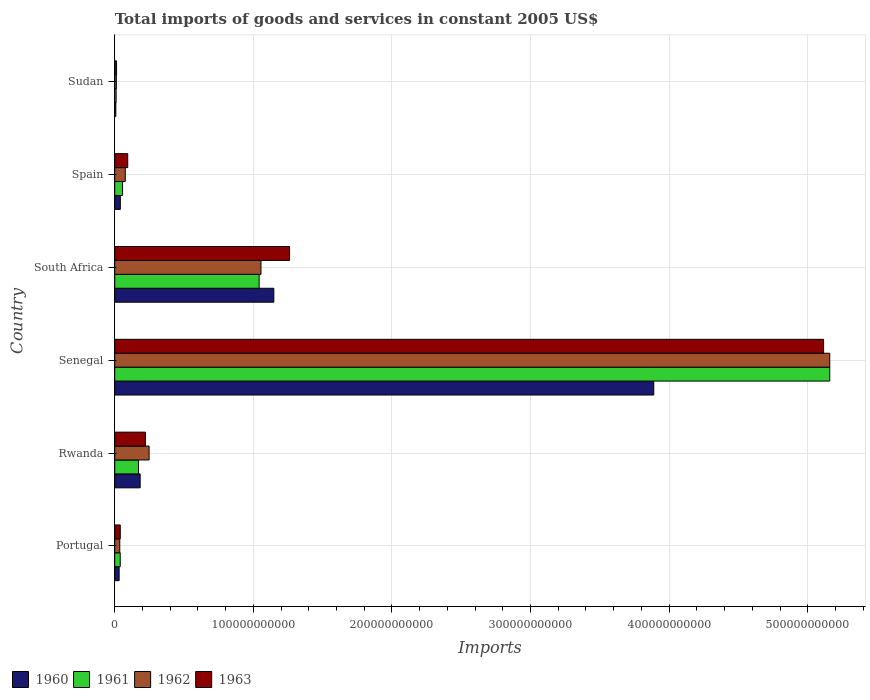How many different coloured bars are there?
Your answer should be very brief. 4. Are the number of bars on each tick of the Y-axis equal?
Make the answer very short. Yes. How many bars are there on the 2nd tick from the top?
Provide a succinct answer. 4. What is the label of the 3rd group of bars from the top?
Offer a terse response. South Africa. What is the total imports of goods and services in 1963 in South Africa?
Your response must be concise. 1.26e+11. Across all countries, what is the maximum total imports of goods and services in 1961?
Your answer should be compact. 5.16e+11. Across all countries, what is the minimum total imports of goods and services in 1961?
Provide a short and direct response. 1.00e+09. In which country was the total imports of goods and services in 1963 maximum?
Your response must be concise. Senegal. In which country was the total imports of goods and services in 1961 minimum?
Offer a terse response. Sudan. What is the total total imports of goods and services in 1963 in the graph?
Offer a terse response. 6.74e+11. What is the difference between the total imports of goods and services in 1960 in Rwanda and that in Spain?
Provide a short and direct response. 1.43e+1. What is the difference between the total imports of goods and services in 1961 in Portugal and the total imports of goods and services in 1960 in Senegal?
Your response must be concise. -3.85e+11. What is the average total imports of goods and services in 1960 per country?
Offer a very short reply. 8.83e+1. What is the difference between the total imports of goods and services in 1962 and total imports of goods and services in 1960 in Sudan?
Your response must be concise. 3.65e+08. In how many countries, is the total imports of goods and services in 1960 greater than 460000000000 US$?
Keep it short and to the point. 0. What is the ratio of the total imports of goods and services in 1962 in Portugal to that in Spain?
Give a very brief answer. 0.48. Is the difference between the total imports of goods and services in 1962 in Rwanda and Senegal greater than the difference between the total imports of goods and services in 1960 in Rwanda and Senegal?
Offer a very short reply. No. What is the difference between the highest and the second highest total imports of goods and services in 1963?
Keep it short and to the point. 3.85e+11. What is the difference between the highest and the lowest total imports of goods and services in 1962?
Provide a short and direct response. 5.15e+11. In how many countries, is the total imports of goods and services in 1962 greater than the average total imports of goods and services in 1962 taken over all countries?
Ensure brevity in your answer.  1. Is it the case that in every country, the sum of the total imports of goods and services in 1962 and total imports of goods and services in 1960 is greater than the sum of total imports of goods and services in 1963 and total imports of goods and services in 1961?
Give a very brief answer. No. Are all the bars in the graph horizontal?
Ensure brevity in your answer.  Yes. What is the difference between two consecutive major ticks on the X-axis?
Ensure brevity in your answer.  1.00e+11. What is the title of the graph?
Provide a succinct answer. Total imports of goods and services in constant 2005 US$. What is the label or title of the X-axis?
Give a very brief answer. Imports. What is the label or title of the Y-axis?
Provide a succinct answer. Country. What is the Imports of 1960 in Portugal?
Ensure brevity in your answer.  3.17e+09. What is the Imports of 1961 in Portugal?
Your response must be concise. 3.96e+09. What is the Imports of 1962 in Portugal?
Keep it short and to the point. 3.62e+09. What is the Imports of 1963 in Portugal?
Ensure brevity in your answer.  3.98e+09. What is the Imports in 1960 in Rwanda?
Provide a succinct answer. 1.83e+1. What is the Imports in 1961 in Rwanda?
Keep it short and to the point. 1.71e+1. What is the Imports in 1962 in Rwanda?
Provide a short and direct response. 2.48e+1. What is the Imports in 1963 in Rwanda?
Keep it short and to the point. 2.21e+1. What is the Imports in 1960 in Senegal?
Offer a terse response. 3.89e+11. What is the Imports in 1961 in Senegal?
Make the answer very short. 5.16e+11. What is the Imports of 1962 in Senegal?
Provide a short and direct response. 5.16e+11. What is the Imports in 1963 in Senegal?
Keep it short and to the point. 5.11e+11. What is the Imports in 1960 in South Africa?
Offer a very short reply. 1.15e+11. What is the Imports of 1961 in South Africa?
Your response must be concise. 1.04e+11. What is the Imports of 1962 in South Africa?
Make the answer very short. 1.05e+11. What is the Imports in 1963 in South Africa?
Your response must be concise. 1.26e+11. What is the Imports of 1960 in Spain?
Your answer should be compact. 4.02e+09. What is the Imports of 1961 in Spain?
Keep it short and to the point. 5.64e+09. What is the Imports of 1962 in Spain?
Your answer should be very brief. 7.58e+09. What is the Imports in 1963 in Spain?
Offer a very short reply. 9.36e+09. What is the Imports in 1960 in Sudan?
Provide a succinct answer. 7.79e+08. What is the Imports of 1961 in Sudan?
Give a very brief answer. 1.00e+09. What is the Imports of 1962 in Sudan?
Your answer should be very brief. 1.14e+09. What is the Imports of 1963 in Sudan?
Give a very brief answer. 1.28e+09. Across all countries, what is the maximum Imports in 1960?
Give a very brief answer. 3.89e+11. Across all countries, what is the maximum Imports in 1961?
Make the answer very short. 5.16e+11. Across all countries, what is the maximum Imports of 1962?
Keep it short and to the point. 5.16e+11. Across all countries, what is the maximum Imports of 1963?
Offer a terse response. 5.11e+11. Across all countries, what is the minimum Imports of 1960?
Offer a very short reply. 7.79e+08. Across all countries, what is the minimum Imports of 1961?
Keep it short and to the point. 1.00e+09. Across all countries, what is the minimum Imports of 1962?
Your response must be concise. 1.14e+09. Across all countries, what is the minimum Imports of 1963?
Offer a very short reply. 1.28e+09. What is the total Imports in 1960 in the graph?
Offer a terse response. 5.30e+11. What is the total Imports in 1961 in the graph?
Give a very brief answer. 6.48e+11. What is the total Imports of 1962 in the graph?
Your response must be concise. 6.59e+11. What is the total Imports in 1963 in the graph?
Your answer should be very brief. 6.74e+11. What is the difference between the Imports of 1960 in Portugal and that in Rwanda?
Your answer should be very brief. -1.52e+1. What is the difference between the Imports of 1961 in Portugal and that in Rwanda?
Your response must be concise. -1.32e+1. What is the difference between the Imports in 1962 in Portugal and that in Rwanda?
Provide a succinct answer. -2.12e+1. What is the difference between the Imports in 1963 in Portugal and that in Rwanda?
Your answer should be very brief. -1.81e+1. What is the difference between the Imports in 1960 in Portugal and that in Senegal?
Your answer should be very brief. -3.86e+11. What is the difference between the Imports of 1961 in Portugal and that in Senegal?
Ensure brevity in your answer.  -5.12e+11. What is the difference between the Imports in 1962 in Portugal and that in Senegal?
Your answer should be very brief. -5.12e+11. What is the difference between the Imports in 1963 in Portugal and that in Senegal?
Offer a terse response. -5.07e+11. What is the difference between the Imports in 1960 in Portugal and that in South Africa?
Keep it short and to the point. -1.12e+11. What is the difference between the Imports of 1961 in Portugal and that in South Africa?
Provide a short and direct response. -1.00e+11. What is the difference between the Imports in 1962 in Portugal and that in South Africa?
Offer a very short reply. -1.02e+11. What is the difference between the Imports of 1963 in Portugal and that in South Africa?
Keep it short and to the point. -1.22e+11. What is the difference between the Imports of 1960 in Portugal and that in Spain?
Your answer should be very brief. -8.56e+08. What is the difference between the Imports in 1961 in Portugal and that in Spain?
Provide a short and direct response. -1.68e+09. What is the difference between the Imports in 1962 in Portugal and that in Spain?
Ensure brevity in your answer.  -3.96e+09. What is the difference between the Imports of 1963 in Portugal and that in Spain?
Provide a succinct answer. -5.39e+09. What is the difference between the Imports of 1960 in Portugal and that in Sudan?
Your response must be concise. 2.39e+09. What is the difference between the Imports of 1961 in Portugal and that in Sudan?
Your answer should be very brief. 2.95e+09. What is the difference between the Imports in 1962 in Portugal and that in Sudan?
Your answer should be very brief. 2.48e+09. What is the difference between the Imports of 1963 in Portugal and that in Sudan?
Your answer should be compact. 2.69e+09. What is the difference between the Imports of 1960 in Rwanda and that in Senegal?
Make the answer very short. -3.71e+11. What is the difference between the Imports in 1961 in Rwanda and that in Senegal?
Offer a very short reply. -4.99e+11. What is the difference between the Imports in 1962 in Rwanda and that in Senegal?
Give a very brief answer. -4.91e+11. What is the difference between the Imports of 1963 in Rwanda and that in Senegal?
Offer a very short reply. -4.89e+11. What is the difference between the Imports of 1960 in Rwanda and that in South Africa?
Your answer should be very brief. -9.65e+1. What is the difference between the Imports of 1961 in Rwanda and that in South Africa?
Give a very brief answer. -8.71e+1. What is the difference between the Imports in 1962 in Rwanda and that in South Africa?
Make the answer very short. -8.07e+1. What is the difference between the Imports of 1963 in Rwanda and that in South Africa?
Ensure brevity in your answer.  -1.04e+11. What is the difference between the Imports in 1960 in Rwanda and that in Spain?
Your answer should be compact. 1.43e+1. What is the difference between the Imports of 1961 in Rwanda and that in Spain?
Your answer should be compact. 1.15e+1. What is the difference between the Imports of 1962 in Rwanda and that in Spain?
Keep it short and to the point. 1.72e+1. What is the difference between the Imports in 1963 in Rwanda and that in Spain?
Give a very brief answer. 1.27e+1. What is the difference between the Imports in 1960 in Rwanda and that in Sudan?
Ensure brevity in your answer.  1.75e+1. What is the difference between the Imports of 1961 in Rwanda and that in Sudan?
Provide a succinct answer. 1.61e+1. What is the difference between the Imports of 1962 in Rwanda and that in Sudan?
Keep it short and to the point. 2.36e+1. What is the difference between the Imports of 1963 in Rwanda and that in Sudan?
Make the answer very short. 2.08e+1. What is the difference between the Imports in 1960 in Senegal and that in South Africa?
Your answer should be very brief. 2.74e+11. What is the difference between the Imports in 1961 in Senegal and that in South Africa?
Offer a very short reply. 4.12e+11. What is the difference between the Imports in 1962 in Senegal and that in South Africa?
Keep it short and to the point. 4.10e+11. What is the difference between the Imports in 1963 in Senegal and that in South Africa?
Keep it short and to the point. 3.85e+11. What is the difference between the Imports in 1960 in Senegal and that in Spain?
Offer a terse response. 3.85e+11. What is the difference between the Imports in 1961 in Senegal and that in Spain?
Keep it short and to the point. 5.10e+11. What is the difference between the Imports in 1962 in Senegal and that in Spain?
Offer a terse response. 5.08e+11. What is the difference between the Imports in 1963 in Senegal and that in Spain?
Give a very brief answer. 5.02e+11. What is the difference between the Imports in 1960 in Senegal and that in Sudan?
Keep it short and to the point. 3.88e+11. What is the difference between the Imports in 1961 in Senegal and that in Sudan?
Provide a succinct answer. 5.15e+11. What is the difference between the Imports in 1962 in Senegal and that in Sudan?
Give a very brief answer. 5.15e+11. What is the difference between the Imports in 1963 in Senegal and that in Sudan?
Your response must be concise. 5.10e+11. What is the difference between the Imports in 1960 in South Africa and that in Spain?
Provide a short and direct response. 1.11e+11. What is the difference between the Imports of 1961 in South Africa and that in Spain?
Ensure brevity in your answer.  9.85e+1. What is the difference between the Imports of 1962 in South Africa and that in Spain?
Your response must be concise. 9.79e+1. What is the difference between the Imports of 1963 in South Africa and that in Spain?
Ensure brevity in your answer.  1.17e+11. What is the difference between the Imports in 1960 in South Africa and that in Sudan?
Offer a very short reply. 1.14e+11. What is the difference between the Imports of 1961 in South Africa and that in Sudan?
Provide a succinct answer. 1.03e+11. What is the difference between the Imports in 1962 in South Africa and that in Sudan?
Offer a very short reply. 1.04e+11. What is the difference between the Imports of 1963 in South Africa and that in Sudan?
Provide a short and direct response. 1.25e+11. What is the difference between the Imports in 1960 in Spain and that in Sudan?
Keep it short and to the point. 3.24e+09. What is the difference between the Imports of 1961 in Spain and that in Sudan?
Provide a succinct answer. 4.63e+09. What is the difference between the Imports of 1962 in Spain and that in Sudan?
Ensure brevity in your answer.  6.44e+09. What is the difference between the Imports of 1963 in Spain and that in Sudan?
Offer a terse response. 8.08e+09. What is the difference between the Imports of 1960 in Portugal and the Imports of 1961 in Rwanda?
Provide a short and direct response. -1.39e+1. What is the difference between the Imports of 1960 in Portugal and the Imports of 1962 in Rwanda?
Your answer should be compact. -2.16e+1. What is the difference between the Imports of 1960 in Portugal and the Imports of 1963 in Rwanda?
Your answer should be very brief. -1.89e+1. What is the difference between the Imports in 1961 in Portugal and the Imports in 1962 in Rwanda?
Offer a very short reply. -2.08e+1. What is the difference between the Imports in 1961 in Portugal and the Imports in 1963 in Rwanda?
Ensure brevity in your answer.  -1.81e+1. What is the difference between the Imports in 1962 in Portugal and the Imports in 1963 in Rwanda?
Your answer should be compact. -1.85e+1. What is the difference between the Imports in 1960 in Portugal and the Imports in 1961 in Senegal?
Provide a succinct answer. -5.13e+11. What is the difference between the Imports in 1960 in Portugal and the Imports in 1962 in Senegal?
Your answer should be compact. -5.13e+11. What is the difference between the Imports in 1960 in Portugal and the Imports in 1963 in Senegal?
Your answer should be compact. -5.08e+11. What is the difference between the Imports in 1961 in Portugal and the Imports in 1962 in Senegal?
Provide a short and direct response. -5.12e+11. What is the difference between the Imports in 1961 in Portugal and the Imports in 1963 in Senegal?
Offer a very short reply. -5.07e+11. What is the difference between the Imports in 1962 in Portugal and the Imports in 1963 in Senegal?
Provide a succinct answer. -5.08e+11. What is the difference between the Imports of 1960 in Portugal and the Imports of 1961 in South Africa?
Offer a very short reply. -1.01e+11. What is the difference between the Imports of 1960 in Portugal and the Imports of 1962 in South Africa?
Offer a very short reply. -1.02e+11. What is the difference between the Imports of 1960 in Portugal and the Imports of 1963 in South Africa?
Ensure brevity in your answer.  -1.23e+11. What is the difference between the Imports of 1961 in Portugal and the Imports of 1962 in South Africa?
Your response must be concise. -1.02e+11. What is the difference between the Imports in 1961 in Portugal and the Imports in 1963 in South Africa?
Keep it short and to the point. -1.22e+11. What is the difference between the Imports of 1962 in Portugal and the Imports of 1963 in South Africa?
Offer a terse response. -1.23e+11. What is the difference between the Imports in 1960 in Portugal and the Imports in 1961 in Spain?
Ensure brevity in your answer.  -2.47e+09. What is the difference between the Imports in 1960 in Portugal and the Imports in 1962 in Spain?
Your answer should be very brief. -4.41e+09. What is the difference between the Imports in 1960 in Portugal and the Imports in 1963 in Spain?
Make the answer very short. -6.19e+09. What is the difference between the Imports of 1961 in Portugal and the Imports of 1962 in Spain?
Provide a short and direct response. -3.62e+09. What is the difference between the Imports in 1961 in Portugal and the Imports in 1963 in Spain?
Offer a very short reply. -5.41e+09. What is the difference between the Imports of 1962 in Portugal and the Imports of 1963 in Spain?
Your response must be concise. -5.74e+09. What is the difference between the Imports in 1960 in Portugal and the Imports in 1961 in Sudan?
Your answer should be compact. 2.16e+09. What is the difference between the Imports of 1960 in Portugal and the Imports of 1962 in Sudan?
Provide a short and direct response. 2.02e+09. What is the difference between the Imports in 1960 in Portugal and the Imports in 1963 in Sudan?
Your response must be concise. 1.88e+09. What is the difference between the Imports in 1961 in Portugal and the Imports in 1962 in Sudan?
Ensure brevity in your answer.  2.81e+09. What is the difference between the Imports in 1961 in Portugal and the Imports in 1963 in Sudan?
Keep it short and to the point. 2.67e+09. What is the difference between the Imports in 1962 in Portugal and the Imports in 1963 in Sudan?
Give a very brief answer. 2.34e+09. What is the difference between the Imports in 1960 in Rwanda and the Imports in 1961 in Senegal?
Your response must be concise. -4.98e+11. What is the difference between the Imports in 1960 in Rwanda and the Imports in 1962 in Senegal?
Provide a succinct answer. -4.98e+11. What is the difference between the Imports in 1960 in Rwanda and the Imports in 1963 in Senegal?
Provide a short and direct response. -4.93e+11. What is the difference between the Imports in 1961 in Rwanda and the Imports in 1962 in Senegal?
Offer a very short reply. -4.99e+11. What is the difference between the Imports of 1961 in Rwanda and the Imports of 1963 in Senegal?
Make the answer very short. -4.94e+11. What is the difference between the Imports in 1962 in Rwanda and the Imports in 1963 in Senegal?
Give a very brief answer. -4.87e+11. What is the difference between the Imports in 1960 in Rwanda and the Imports in 1961 in South Africa?
Your response must be concise. -8.59e+1. What is the difference between the Imports in 1960 in Rwanda and the Imports in 1962 in South Africa?
Your response must be concise. -8.72e+1. What is the difference between the Imports in 1960 in Rwanda and the Imports in 1963 in South Africa?
Ensure brevity in your answer.  -1.08e+11. What is the difference between the Imports of 1961 in Rwanda and the Imports of 1962 in South Africa?
Provide a succinct answer. -8.84e+1. What is the difference between the Imports in 1961 in Rwanda and the Imports in 1963 in South Africa?
Keep it short and to the point. -1.09e+11. What is the difference between the Imports in 1962 in Rwanda and the Imports in 1963 in South Africa?
Your answer should be very brief. -1.01e+11. What is the difference between the Imports in 1960 in Rwanda and the Imports in 1961 in Spain?
Your response must be concise. 1.27e+1. What is the difference between the Imports in 1960 in Rwanda and the Imports in 1962 in Spain?
Offer a terse response. 1.07e+1. What is the difference between the Imports in 1960 in Rwanda and the Imports in 1963 in Spain?
Ensure brevity in your answer.  8.96e+09. What is the difference between the Imports of 1961 in Rwanda and the Imports of 1962 in Spain?
Provide a succinct answer. 9.53e+09. What is the difference between the Imports of 1961 in Rwanda and the Imports of 1963 in Spain?
Give a very brief answer. 7.74e+09. What is the difference between the Imports in 1962 in Rwanda and the Imports in 1963 in Spain?
Provide a short and direct response. 1.54e+1. What is the difference between the Imports of 1960 in Rwanda and the Imports of 1961 in Sudan?
Offer a terse response. 1.73e+1. What is the difference between the Imports in 1960 in Rwanda and the Imports in 1962 in Sudan?
Give a very brief answer. 1.72e+1. What is the difference between the Imports in 1960 in Rwanda and the Imports in 1963 in Sudan?
Make the answer very short. 1.70e+1. What is the difference between the Imports of 1961 in Rwanda and the Imports of 1962 in Sudan?
Ensure brevity in your answer.  1.60e+1. What is the difference between the Imports in 1961 in Rwanda and the Imports in 1963 in Sudan?
Offer a very short reply. 1.58e+1. What is the difference between the Imports in 1962 in Rwanda and the Imports in 1963 in Sudan?
Provide a short and direct response. 2.35e+1. What is the difference between the Imports in 1960 in Senegal and the Imports in 1961 in South Africa?
Your answer should be compact. 2.85e+11. What is the difference between the Imports in 1960 in Senegal and the Imports in 1962 in South Africa?
Provide a succinct answer. 2.83e+11. What is the difference between the Imports of 1960 in Senegal and the Imports of 1963 in South Africa?
Make the answer very short. 2.63e+11. What is the difference between the Imports of 1961 in Senegal and the Imports of 1962 in South Africa?
Ensure brevity in your answer.  4.10e+11. What is the difference between the Imports of 1961 in Senegal and the Imports of 1963 in South Africa?
Your response must be concise. 3.90e+11. What is the difference between the Imports in 1962 in Senegal and the Imports in 1963 in South Africa?
Provide a succinct answer. 3.90e+11. What is the difference between the Imports of 1960 in Senegal and the Imports of 1961 in Spain?
Provide a succinct answer. 3.83e+11. What is the difference between the Imports of 1960 in Senegal and the Imports of 1962 in Spain?
Offer a terse response. 3.81e+11. What is the difference between the Imports in 1960 in Senegal and the Imports in 1963 in Spain?
Provide a short and direct response. 3.80e+11. What is the difference between the Imports in 1961 in Senegal and the Imports in 1962 in Spain?
Give a very brief answer. 5.08e+11. What is the difference between the Imports of 1961 in Senegal and the Imports of 1963 in Spain?
Keep it short and to the point. 5.07e+11. What is the difference between the Imports of 1962 in Senegal and the Imports of 1963 in Spain?
Make the answer very short. 5.07e+11. What is the difference between the Imports of 1960 in Senegal and the Imports of 1961 in Sudan?
Provide a succinct answer. 3.88e+11. What is the difference between the Imports of 1960 in Senegal and the Imports of 1962 in Sudan?
Provide a succinct answer. 3.88e+11. What is the difference between the Imports of 1960 in Senegal and the Imports of 1963 in Sudan?
Offer a terse response. 3.88e+11. What is the difference between the Imports in 1961 in Senegal and the Imports in 1962 in Sudan?
Keep it short and to the point. 5.15e+11. What is the difference between the Imports of 1961 in Senegal and the Imports of 1963 in Sudan?
Give a very brief answer. 5.15e+11. What is the difference between the Imports in 1962 in Senegal and the Imports in 1963 in Sudan?
Make the answer very short. 5.15e+11. What is the difference between the Imports of 1960 in South Africa and the Imports of 1961 in Spain?
Your answer should be very brief. 1.09e+11. What is the difference between the Imports in 1960 in South Africa and the Imports in 1962 in Spain?
Ensure brevity in your answer.  1.07e+11. What is the difference between the Imports in 1960 in South Africa and the Imports in 1963 in Spain?
Your response must be concise. 1.05e+11. What is the difference between the Imports of 1961 in South Africa and the Imports of 1962 in Spain?
Give a very brief answer. 9.66e+1. What is the difference between the Imports of 1961 in South Africa and the Imports of 1963 in Spain?
Your answer should be very brief. 9.48e+1. What is the difference between the Imports in 1962 in South Africa and the Imports in 1963 in Spain?
Provide a short and direct response. 9.61e+1. What is the difference between the Imports of 1960 in South Africa and the Imports of 1961 in Sudan?
Offer a terse response. 1.14e+11. What is the difference between the Imports in 1960 in South Africa and the Imports in 1962 in Sudan?
Offer a very short reply. 1.14e+11. What is the difference between the Imports in 1960 in South Africa and the Imports in 1963 in Sudan?
Your response must be concise. 1.13e+11. What is the difference between the Imports in 1961 in South Africa and the Imports in 1962 in Sudan?
Offer a terse response. 1.03e+11. What is the difference between the Imports of 1961 in South Africa and the Imports of 1963 in Sudan?
Offer a very short reply. 1.03e+11. What is the difference between the Imports in 1962 in South Africa and the Imports in 1963 in Sudan?
Your response must be concise. 1.04e+11. What is the difference between the Imports in 1960 in Spain and the Imports in 1961 in Sudan?
Provide a succinct answer. 3.02e+09. What is the difference between the Imports in 1960 in Spain and the Imports in 1962 in Sudan?
Keep it short and to the point. 2.88e+09. What is the difference between the Imports in 1960 in Spain and the Imports in 1963 in Sudan?
Provide a succinct answer. 2.74e+09. What is the difference between the Imports of 1961 in Spain and the Imports of 1962 in Sudan?
Your answer should be compact. 4.49e+09. What is the difference between the Imports in 1961 in Spain and the Imports in 1963 in Sudan?
Give a very brief answer. 4.35e+09. What is the difference between the Imports of 1962 in Spain and the Imports of 1963 in Sudan?
Make the answer very short. 6.30e+09. What is the average Imports in 1960 per country?
Offer a terse response. 8.83e+1. What is the average Imports in 1961 per country?
Your answer should be very brief. 1.08e+11. What is the average Imports in 1962 per country?
Make the answer very short. 1.10e+11. What is the average Imports of 1963 per country?
Provide a short and direct response. 1.12e+11. What is the difference between the Imports of 1960 and Imports of 1961 in Portugal?
Your response must be concise. -7.89e+08. What is the difference between the Imports of 1960 and Imports of 1962 in Portugal?
Your answer should be very brief. -4.52e+08. What is the difference between the Imports of 1960 and Imports of 1963 in Portugal?
Offer a very short reply. -8.09e+08. What is the difference between the Imports of 1961 and Imports of 1962 in Portugal?
Make the answer very short. 3.37e+08. What is the difference between the Imports in 1961 and Imports in 1963 in Portugal?
Offer a terse response. -2.01e+07. What is the difference between the Imports of 1962 and Imports of 1963 in Portugal?
Your response must be concise. -3.57e+08. What is the difference between the Imports in 1960 and Imports in 1961 in Rwanda?
Offer a terse response. 1.22e+09. What is the difference between the Imports in 1960 and Imports in 1962 in Rwanda?
Give a very brief answer. -6.46e+09. What is the difference between the Imports in 1960 and Imports in 1963 in Rwanda?
Your answer should be very brief. -3.77e+09. What is the difference between the Imports in 1961 and Imports in 1962 in Rwanda?
Give a very brief answer. -7.68e+09. What is the difference between the Imports in 1961 and Imports in 1963 in Rwanda?
Provide a short and direct response. -4.99e+09. What is the difference between the Imports of 1962 and Imports of 1963 in Rwanda?
Offer a terse response. 2.68e+09. What is the difference between the Imports of 1960 and Imports of 1961 in Senegal?
Your answer should be very brief. -1.27e+11. What is the difference between the Imports of 1960 and Imports of 1962 in Senegal?
Ensure brevity in your answer.  -1.27e+11. What is the difference between the Imports of 1960 and Imports of 1963 in Senegal?
Offer a terse response. -1.23e+11. What is the difference between the Imports of 1961 and Imports of 1963 in Senegal?
Provide a succinct answer. 4.44e+09. What is the difference between the Imports in 1962 and Imports in 1963 in Senegal?
Your answer should be compact. 4.44e+09. What is the difference between the Imports in 1960 and Imports in 1961 in South Africa?
Offer a very short reply. 1.06e+1. What is the difference between the Imports of 1960 and Imports of 1962 in South Africa?
Your answer should be compact. 9.28e+09. What is the difference between the Imports of 1960 and Imports of 1963 in South Africa?
Provide a succinct answer. -1.13e+1. What is the difference between the Imports of 1961 and Imports of 1962 in South Africa?
Offer a terse response. -1.32e+09. What is the difference between the Imports of 1961 and Imports of 1963 in South Africa?
Offer a terse response. -2.19e+1. What is the difference between the Imports in 1962 and Imports in 1963 in South Africa?
Offer a very short reply. -2.06e+1. What is the difference between the Imports in 1960 and Imports in 1961 in Spain?
Provide a succinct answer. -1.61e+09. What is the difference between the Imports in 1960 and Imports in 1962 in Spain?
Provide a succinct answer. -3.56e+09. What is the difference between the Imports in 1960 and Imports in 1963 in Spain?
Offer a terse response. -5.34e+09. What is the difference between the Imports of 1961 and Imports of 1962 in Spain?
Offer a very short reply. -1.94e+09. What is the difference between the Imports of 1961 and Imports of 1963 in Spain?
Offer a very short reply. -3.72e+09. What is the difference between the Imports of 1962 and Imports of 1963 in Spain?
Your response must be concise. -1.78e+09. What is the difference between the Imports in 1960 and Imports in 1961 in Sudan?
Offer a terse response. -2.25e+08. What is the difference between the Imports in 1960 and Imports in 1962 in Sudan?
Offer a very short reply. -3.65e+08. What is the difference between the Imports of 1960 and Imports of 1963 in Sudan?
Provide a short and direct response. -5.04e+08. What is the difference between the Imports in 1961 and Imports in 1962 in Sudan?
Provide a short and direct response. -1.39e+08. What is the difference between the Imports of 1961 and Imports of 1963 in Sudan?
Keep it short and to the point. -2.79e+08. What is the difference between the Imports of 1962 and Imports of 1963 in Sudan?
Your answer should be compact. -1.39e+08. What is the ratio of the Imports of 1960 in Portugal to that in Rwanda?
Make the answer very short. 0.17. What is the ratio of the Imports of 1961 in Portugal to that in Rwanda?
Give a very brief answer. 0.23. What is the ratio of the Imports in 1962 in Portugal to that in Rwanda?
Ensure brevity in your answer.  0.15. What is the ratio of the Imports of 1963 in Portugal to that in Rwanda?
Provide a succinct answer. 0.18. What is the ratio of the Imports of 1960 in Portugal to that in Senegal?
Ensure brevity in your answer.  0.01. What is the ratio of the Imports of 1961 in Portugal to that in Senegal?
Your response must be concise. 0.01. What is the ratio of the Imports of 1962 in Portugal to that in Senegal?
Ensure brevity in your answer.  0.01. What is the ratio of the Imports of 1963 in Portugal to that in Senegal?
Make the answer very short. 0.01. What is the ratio of the Imports of 1960 in Portugal to that in South Africa?
Your response must be concise. 0.03. What is the ratio of the Imports in 1961 in Portugal to that in South Africa?
Your response must be concise. 0.04. What is the ratio of the Imports of 1962 in Portugal to that in South Africa?
Provide a succinct answer. 0.03. What is the ratio of the Imports in 1963 in Portugal to that in South Africa?
Your answer should be compact. 0.03. What is the ratio of the Imports in 1960 in Portugal to that in Spain?
Keep it short and to the point. 0.79. What is the ratio of the Imports in 1961 in Portugal to that in Spain?
Offer a very short reply. 0.7. What is the ratio of the Imports in 1962 in Portugal to that in Spain?
Keep it short and to the point. 0.48. What is the ratio of the Imports of 1963 in Portugal to that in Spain?
Your answer should be compact. 0.42. What is the ratio of the Imports in 1960 in Portugal to that in Sudan?
Give a very brief answer. 4.06. What is the ratio of the Imports of 1961 in Portugal to that in Sudan?
Offer a very short reply. 3.94. What is the ratio of the Imports of 1962 in Portugal to that in Sudan?
Keep it short and to the point. 3.16. What is the ratio of the Imports in 1963 in Portugal to that in Sudan?
Your answer should be very brief. 3.1. What is the ratio of the Imports of 1960 in Rwanda to that in Senegal?
Your answer should be compact. 0.05. What is the ratio of the Imports of 1961 in Rwanda to that in Senegal?
Provide a short and direct response. 0.03. What is the ratio of the Imports in 1962 in Rwanda to that in Senegal?
Make the answer very short. 0.05. What is the ratio of the Imports in 1963 in Rwanda to that in Senegal?
Give a very brief answer. 0.04. What is the ratio of the Imports in 1960 in Rwanda to that in South Africa?
Your answer should be compact. 0.16. What is the ratio of the Imports in 1961 in Rwanda to that in South Africa?
Your answer should be compact. 0.16. What is the ratio of the Imports in 1962 in Rwanda to that in South Africa?
Offer a terse response. 0.23. What is the ratio of the Imports in 1963 in Rwanda to that in South Africa?
Offer a terse response. 0.18. What is the ratio of the Imports of 1960 in Rwanda to that in Spain?
Offer a terse response. 4.55. What is the ratio of the Imports in 1961 in Rwanda to that in Spain?
Ensure brevity in your answer.  3.03. What is the ratio of the Imports in 1962 in Rwanda to that in Spain?
Offer a terse response. 3.27. What is the ratio of the Imports of 1963 in Rwanda to that in Spain?
Keep it short and to the point. 2.36. What is the ratio of the Imports of 1960 in Rwanda to that in Sudan?
Make the answer very short. 23.52. What is the ratio of the Imports of 1961 in Rwanda to that in Sudan?
Ensure brevity in your answer.  17.03. What is the ratio of the Imports of 1962 in Rwanda to that in Sudan?
Provide a short and direct response. 21.67. What is the ratio of the Imports in 1963 in Rwanda to that in Sudan?
Your answer should be compact. 17.22. What is the ratio of the Imports of 1960 in Senegal to that in South Africa?
Your answer should be compact. 3.39. What is the ratio of the Imports in 1961 in Senegal to that in South Africa?
Keep it short and to the point. 4.95. What is the ratio of the Imports of 1962 in Senegal to that in South Africa?
Your answer should be compact. 4.89. What is the ratio of the Imports of 1963 in Senegal to that in South Africa?
Your answer should be compact. 4.06. What is the ratio of the Imports in 1960 in Senegal to that in Spain?
Make the answer very short. 96.67. What is the ratio of the Imports of 1961 in Senegal to that in Spain?
Offer a terse response. 91.51. What is the ratio of the Imports of 1962 in Senegal to that in Spain?
Provide a succinct answer. 68.06. What is the ratio of the Imports of 1963 in Senegal to that in Spain?
Provide a succinct answer. 54.63. What is the ratio of the Imports in 1960 in Senegal to that in Sudan?
Keep it short and to the point. 499.07. What is the ratio of the Imports in 1961 in Senegal to that in Sudan?
Ensure brevity in your answer.  513.64. What is the ratio of the Imports in 1962 in Senegal to that in Sudan?
Your response must be concise. 451.01. What is the ratio of the Imports in 1963 in Senegal to that in Sudan?
Your response must be concise. 398.54. What is the ratio of the Imports of 1960 in South Africa to that in Spain?
Offer a terse response. 28.53. What is the ratio of the Imports in 1961 in South Africa to that in Spain?
Your answer should be very brief. 18.48. What is the ratio of the Imports in 1962 in South Africa to that in Spain?
Keep it short and to the point. 13.92. What is the ratio of the Imports in 1963 in South Africa to that in Spain?
Keep it short and to the point. 13.47. What is the ratio of the Imports in 1960 in South Africa to that in Sudan?
Your answer should be very brief. 147.29. What is the ratio of the Imports of 1961 in South Africa to that in Sudan?
Provide a succinct answer. 103.72. What is the ratio of the Imports in 1962 in South Africa to that in Sudan?
Ensure brevity in your answer.  92.23. What is the ratio of the Imports in 1963 in South Africa to that in Sudan?
Your response must be concise. 98.28. What is the ratio of the Imports in 1960 in Spain to that in Sudan?
Your response must be concise. 5.16. What is the ratio of the Imports of 1961 in Spain to that in Sudan?
Give a very brief answer. 5.61. What is the ratio of the Imports of 1962 in Spain to that in Sudan?
Offer a terse response. 6.63. What is the ratio of the Imports in 1963 in Spain to that in Sudan?
Your answer should be very brief. 7.3. What is the difference between the highest and the second highest Imports in 1960?
Your answer should be very brief. 2.74e+11. What is the difference between the highest and the second highest Imports of 1961?
Offer a very short reply. 4.12e+11. What is the difference between the highest and the second highest Imports of 1962?
Give a very brief answer. 4.10e+11. What is the difference between the highest and the second highest Imports of 1963?
Your answer should be very brief. 3.85e+11. What is the difference between the highest and the lowest Imports in 1960?
Offer a terse response. 3.88e+11. What is the difference between the highest and the lowest Imports of 1961?
Your response must be concise. 5.15e+11. What is the difference between the highest and the lowest Imports in 1962?
Ensure brevity in your answer.  5.15e+11. What is the difference between the highest and the lowest Imports of 1963?
Make the answer very short. 5.10e+11. 